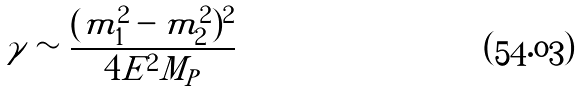Convert formula to latex. <formula><loc_0><loc_0><loc_500><loc_500>\gamma \sim \frac { ( m _ { 1 } ^ { 2 } - m _ { 2 } ^ { 2 } ) ^ { 2 } } { 4 E ^ { 2 } M _ { P } }</formula> 